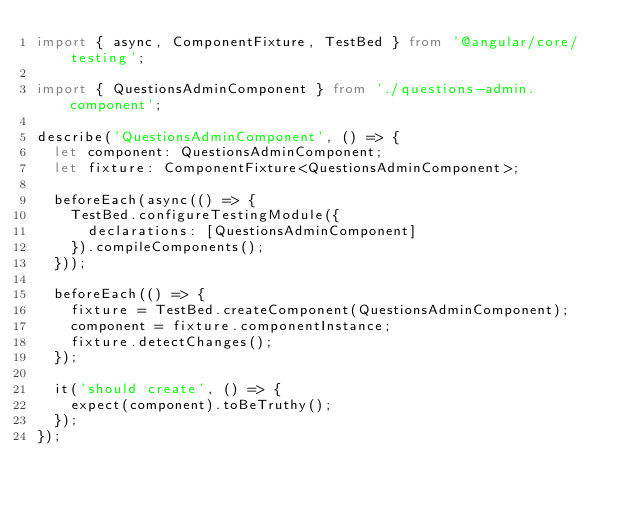<code> <loc_0><loc_0><loc_500><loc_500><_TypeScript_>import { async, ComponentFixture, TestBed } from '@angular/core/testing';

import { QuestionsAdminComponent } from './questions-admin.component';

describe('QuestionsAdminComponent', () => {
  let component: QuestionsAdminComponent;
  let fixture: ComponentFixture<QuestionsAdminComponent>;

  beforeEach(async(() => {
    TestBed.configureTestingModule({
      declarations: [QuestionsAdminComponent]
    }).compileComponents();
  }));

  beforeEach(() => {
    fixture = TestBed.createComponent(QuestionsAdminComponent);
    component = fixture.componentInstance;
    fixture.detectChanges();
  });

  it('should create', () => {
    expect(component).toBeTruthy();
  });
});
</code> 